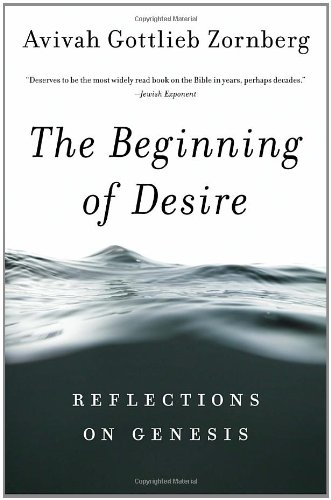What type of book is this? This is a book in the genre of Religion & Spirituality, specifically providing scholarly yet accessible reflections on biblical narratives to draw spiritual and existential insights. 